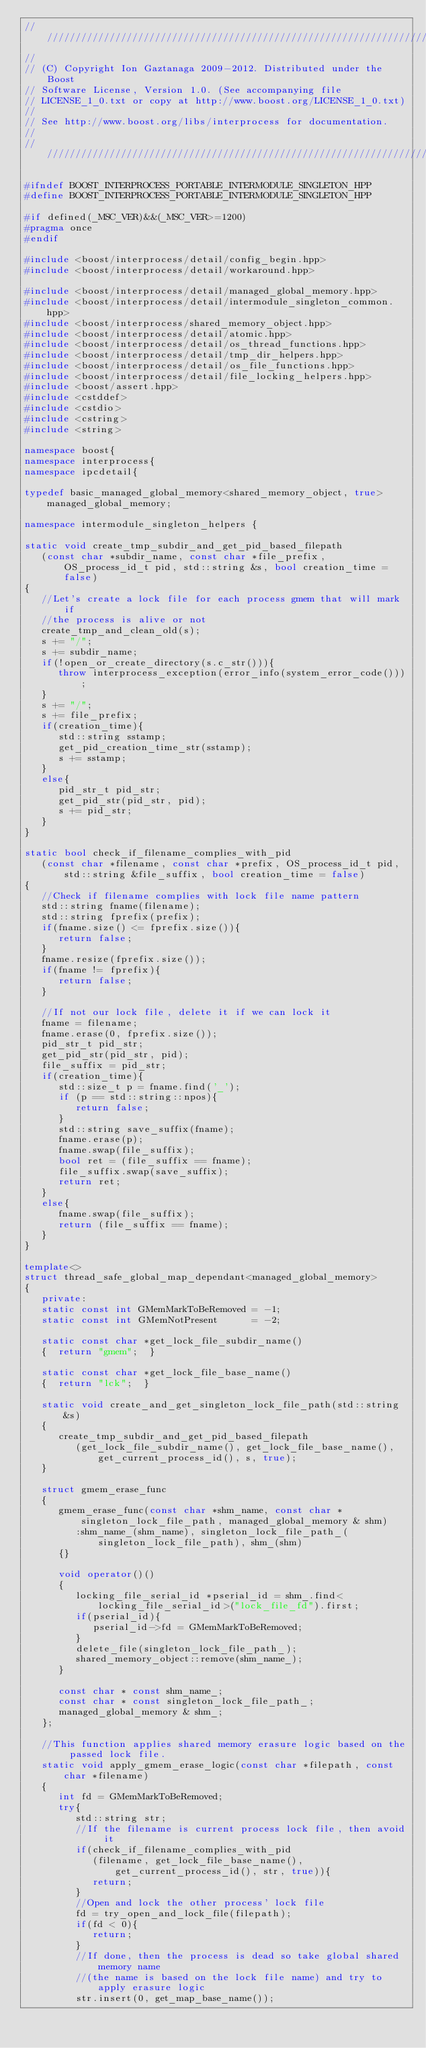Convert code to text. <code><loc_0><loc_0><loc_500><loc_500><_C++_>//////////////////////////////////////////////////////////////////////////////
//
// (C) Copyright Ion Gaztanaga 2009-2012. Distributed under the Boost
// Software License, Version 1.0. (See accompanying file
// LICENSE_1_0.txt or copy at http://www.boost.org/LICENSE_1_0.txt)
//
// See http://www.boost.org/libs/interprocess for documentation.
//
//////////////////////////////////////////////////////////////////////////////

#ifndef BOOST_INTERPROCESS_PORTABLE_INTERMODULE_SINGLETON_HPP
#define BOOST_INTERPROCESS_PORTABLE_INTERMODULE_SINGLETON_HPP

#if defined(_MSC_VER)&&(_MSC_VER>=1200)
#pragma once
#endif

#include <boost/interprocess/detail/config_begin.hpp>
#include <boost/interprocess/detail/workaround.hpp>

#include <boost/interprocess/detail/managed_global_memory.hpp>
#include <boost/interprocess/detail/intermodule_singleton_common.hpp>
#include <boost/interprocess/shared_memory_object.hpp>
#include <boost/interprocess/detail/atomic.hpp>
#include <boost/interprocess/detail/os_thread_functions.hpp>
#include <boost/interprocess/detail/tmp_dir_helpers.hpp>
#include <boost/interprocess/detail/os_file_functions.hpp>
#include <boost/interprocess/detail/file_locking_helpers.hpp>
#include <boost/assert.hpp>
#include <cstddef>
#include <cstdio>
#include <cstring>
#include <string>

namespace boost{
namespace interprocess{
namespace ipcdetail{

typedef basic_managed_global_memory<shared_memory_object, true>    managed_global_memory;

namespace intermodule_singleton_helpers {

static void create_tmp_subdir_and_get_pid_based_filepath
   (const char *subdir_name, const char *file_prefix, OS_process_id_t pid, std::string &s, bool creation_time = false)
{
   //Let's create a lock file for each process gmem that will mark if
   //the process is alive or not
   create_tmp_and_clean_old(s);
   s += "/";
   s += subdir_name;
   if(!open_or_create_directory(s.c_str())){
      throw interprocess_exception(error_info(system_error_code()));
   }
   s += "/";
   s += file_prefix;
   if(creation_time){
      std::string sstamp;
      get_pid_creation_time_str(sstamp);
      s += sstamp;
   }
   else{
      pid_str_t pid_str;
      get_pid_str(pid_str, pid);
      s += pid_str;
   }
}

static bool check_if_filename_complies_with_pid
   (const char *filename, const char *prefix, OS_process_id_t pid, std::string &file_suffix, bool creation_time = false)
{
   //Check if filename complies with lock file name pattern
   std::string fname(filename);
   std::string fprefix(prefix);
   if(fname.size() <= fprefix.size()){
      return false;
   }
   fname.resize(fprefix.size());
   if(fname != fprefix){
      return false;
   }

   //If not our lock file, delete it if we can lock it
   fname = filename;
   fname.erase(0, fprefix.size());
   pid_str_t pid_str;
   get_pid_str(pid_str, pid);
   file_suffix = pid_str;
   if(creation_time){
      std::size_t p = fname.find('_');
      if (p == std::string::npos){
         return false;
      }
      std::string save_suffix(fname);
      fname.erase(p);
      fname.swap(file_suffix);
      bool ret = (file_suffix == fname);
      file_suffix.swap(save_suffix);
      return ret;
   }
   else{
      fname.swap(file_suffix);
      return (file_suffix == fname);
   }
}

template<>
struct thread_safe_global_map_dependant<managed_global_memory>
{
   private:
   static const int GMemMarkToBeRemoved = -1;
   static const int GMemNotPresent      = -2;

   static const char *get_lock_file_subdir_name()
   {  return "gmem";  }

   static const char *get_lock_file_base_name()
   {  return "lck";  }

   static void create_and_get_singleton_lock_file_path(std::string &s)
   {
      create_tmp_subdir_and_get_pid_based_filepath
         (get_lock_file_subdir_name(), get_lock_file_base_name(), get_current_process_id(), s, true);
   }

   struct gmem_erase_func
   {
      gmem_erase_func(const char *shm_name, const char *singleton_lock_file_path, managed_global_memory & shm)
         :shm_name_(shm_name), singleton_lock_file_path_(singleton_lock_file_path), shm_(shm)
      {}

      void operator()()
      {
         locking_file_serial_id *pserial_id = shm_.find<locking_file_serial_id>("lock_file_fd").first;
         if(pserial_id){
            pserial_id->fd = GMemMarkToBeRemoved;
         }
         delete_file(singleton_lock_file_path_);
         shared_memory_object::remove(shm_name_);
      }

      const char * const shm_name_;
      const char * const singleton_lock_file_path_;
      managed_global_memory & shm_;
   };

   //This function applies shared memory erasure logic based on the passed lock file.
   static void apply_gmem_erase_logic(const char *filepath, const char *filename)
   {
      int fd = GMemMarkToBeRemoved;
      try{
         std::string str;
         //If the filename is current process lock file, then avoid it
         if(check_if_filename_complies_with_pid
            (filename, get_lock_file_base_name(), get_current_process_id(), str, true)){
            return;
         }
         //Open and lock the other process' lock file
         fd = try_open_and_lock_file(filepath);
         if(fd < 0){
            return;
         }
         //If done, then the process is dead so take global shared memory name
         //(the name is based on the lock file name) and try to apply erasure logic
         str.insert(0, get_map_base_name());</code> 